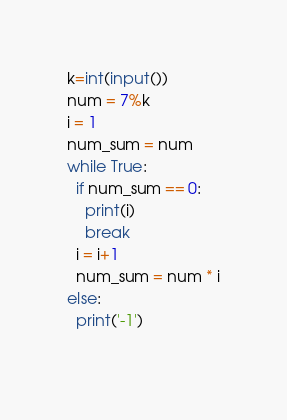Convert code to text. <code><loc_0><loc_0><loc_500><loc_500><_Python_>k=int(input())
num = 7%k
i = 1
num_sum = num
while True:
  if num_sum == 0:
    print(i)
    break
  i = i+1
  num_sum = num * i
else:
  print('-1')
  </code> 